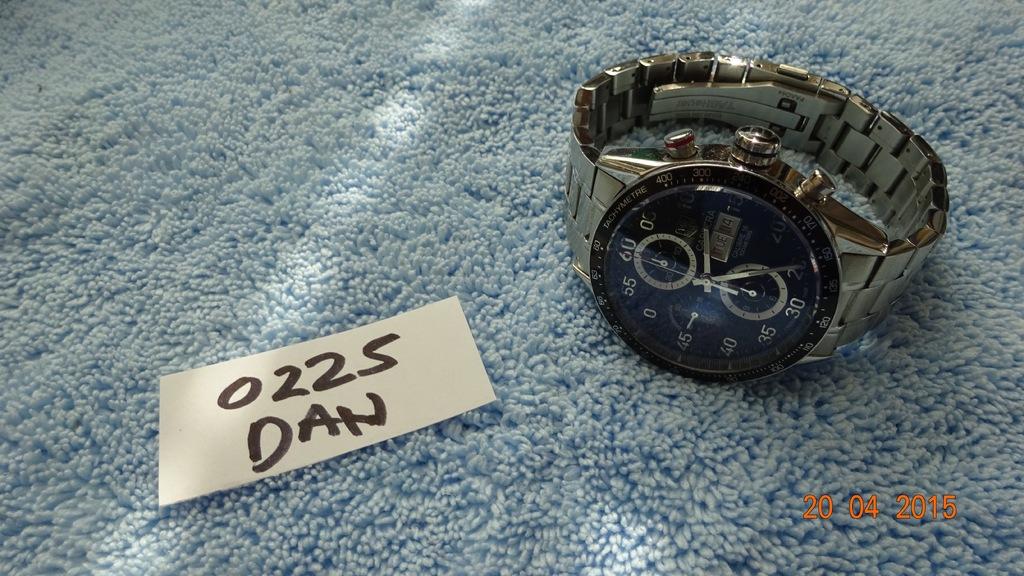Who owns the watch?
Provide a succinct answer. Dan. 